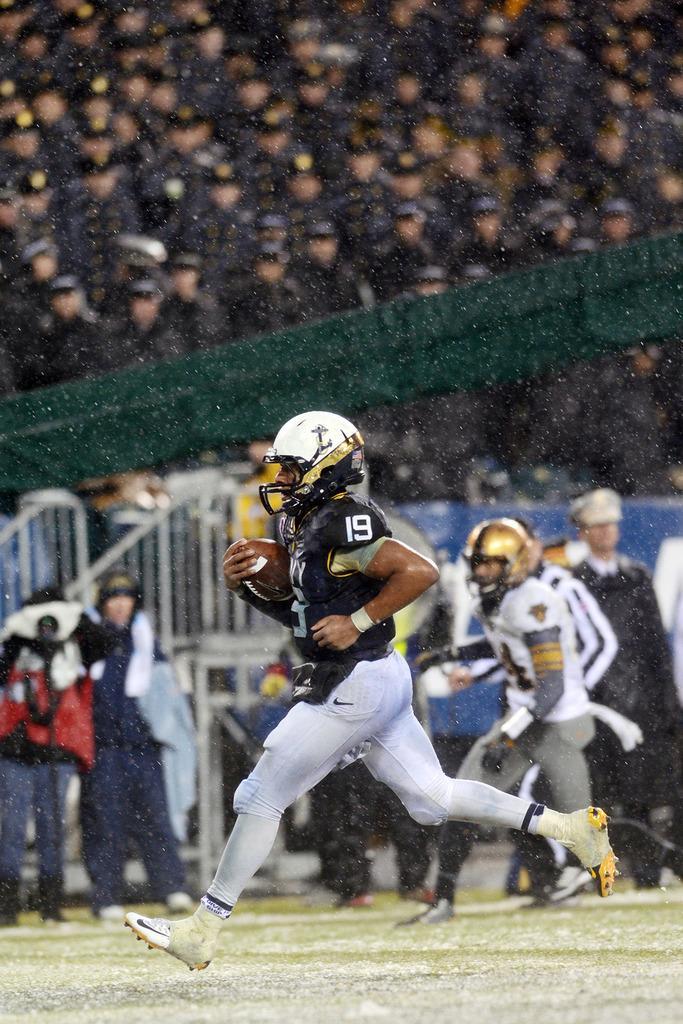Describe this image in one or two sentences. In this image I can see the group of people are on the ground. These people are wearing the different color dresses and I can see few people with the helmets. One person is holding the ball. In the background I can see the railing and many people but it is blurry. 